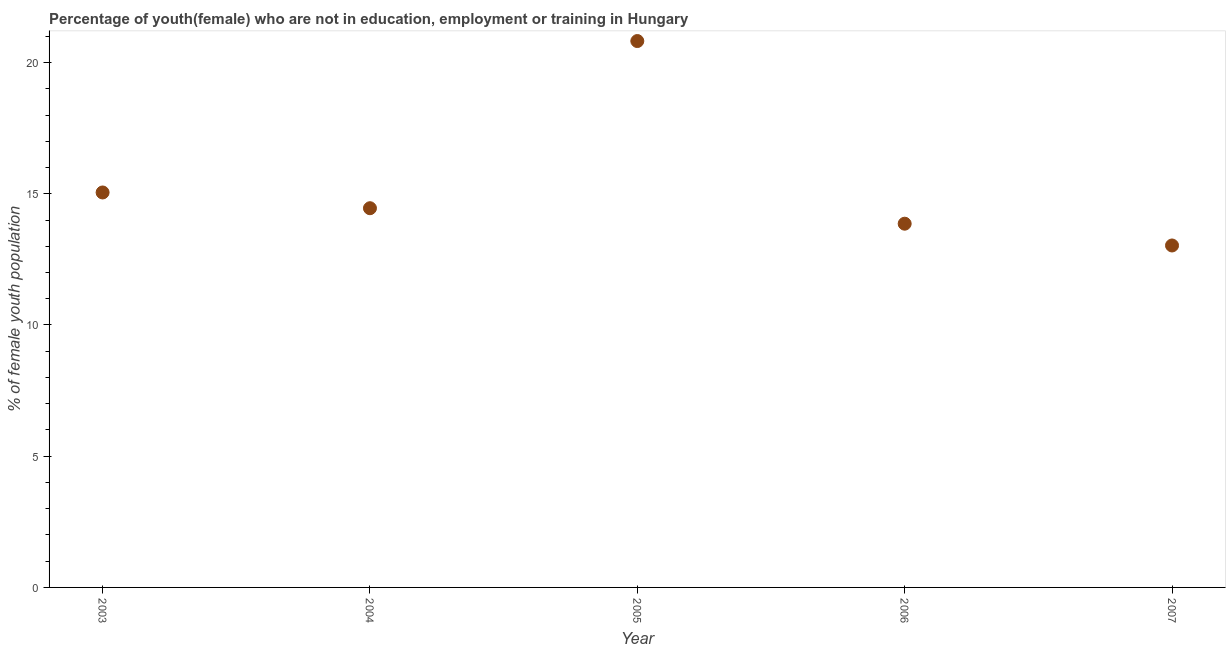What is the unemployed female youth population in 2006?
Your answer should be compact. 13.86. Across all years, what is the maximum unemployed female youth population?
Ensure brevity in your answer.  20.82. Across all years, what is the minimum unemployed female youth population?
Give a very brief answer. 13.03. In which year was the unemployed female youth population maximum?
Your answer should be compact. 2005. What is the sum of the unemployed female youth population?
Offer a terse response. 77.21. What is the difference between the unemployed female youth population in 2004 and 2007?
Your response must be concise. 1.42. What is the average unemployed female youth population per year?
Offer a terse response. 15.44. What is the median unemployed female youth population?
Keep it short and to the point. 14.45. In how many years, is the unemployed female youth population greater than 1 %?
Keep it short and to the point. 5. Do a majority of the years between 2004 and 2006 (inclusive) have unemployed female youth population greater than 8 %?
Give a very brief answer. Yes. What is the ratio of the unemployed female youth population in 2003 to that in 2007?
Offer a terse response. 1.16. Is the unemployed female youth population in 2004 less than that in 2006?
Your answer should be compact. No. Is the difference between the unemployed female youth population in 2003 and 2005 greater than the difference between any two years?
Keep it short and to the point. No. What is the difference between the highest and the second highest unemployed female youth population?
Your answer should be compact. 5.77. What is the difference between the highest and the lowest unemployed female youth population?
Your answer should be compact. 7.79. In how many years, is the unemployed female youth population greater than the average unemployed female youth population taken over all years?
Your response must be concise. 1. Does the unemployed female youth population monotonically increase over the years?
Offer a terse response. No. What is the difference between two consecutive major ticks on the Y-axis?
Keep it short and to the point. 5. Are the values on the major ticks of Y-axis written in scientific E-notation?
Your response must be concise. No. Does the graph contain any zero values?
Make the answer very short. No. What is the title of the graph?
Your answer should be compact. Percentage of youth(female) who are not in education, employment or training in Hungary. What is the label or title of the Y-axis?
Provide a short and direct response. % of female youth population. What is the % of female youth population in 2003?
Your response must be concise. 15.05. What is the % of female youth population in 2004?
Your answer should be very brief. 14.45. What is the % of female youth population in 2005?
Ensure brevity in your answer.  20.82. What is the % of female youth population in 2006?
Your response must be concise. 13.86. What is the % of female youth population in 2007?
Offer a terse response. 13.03. What is the difference between the % of female youth population in 2003 and 2005?
Provide a short and direct response. -5.77. What is the difference between the % of female youth population in 2003 and 2006?
Provide a succinct answer. 1.19. What is the difference between the % of female youth population in 2003 and 2007?
Provide a short and direct response. 2.02. What is the difference between the % of female youth population in 2004 and 2005?
Your answer should be very brief. -6.37. What is the difference between the % of female youth population in 2004 and 2006?
Keep it short and to the point. 0.59. What is the difference between the % of female youth population in 2004 and 2007?
Offer a very short reply. 1.42. What is the difference between the % of female youth population in 2005 and 2006?
Provide a short and direct response. 6.96. What is the difference between the % of female youth population in 2005 and 2007?
Your answer should be compact. 7.79. What is the difference between the % of female youth population in 2006 and 2007?
Give a very brief answer. 0.83. What is the ratio of the % of female youth population in 2003 to that in 2004?
Provide a succinct answer. 1.04. What is the ratio of the % of female youth population in 2003 to that in 2005?
Offer a very short reply. 0.72. What is the ratio of the % of female youth population in 2003 to that in 2006?
Ensure brevity in your answer.  1.09. What is the ratio of the % of female youth population in 2003 to that in 2007?
Provide a succinct answer. 1.16. What is the ratio of the % of female youth population in 2004 to that in 2005?
Offer a very short reply. 0.69. What is the ratio of the % of female youth population in 2004 to that in 2006?
Give a very brief answer. 1.04. What is the ratio of the % of female youth population in 2004 to that in 2007?
Provide a short and direct response. 1.11. What is the ratio of the % of female youth population in 2005 to that in 2006?
Provide a succinct answer. 1.5. What is the ratio of the % of female youth population in 2005 to that in 2007?
Ensure brevity in your answer.  1.6. What is the ratio of the % of female youth population in 2006 to that in 2007?
Your response must be concise. 1.06. 